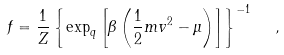<formula> <loc_0><loc_0><loc_500><loc_500>f = \frac { 1 } { Z } \left \{ \exp _ { q } \left [ \beta \left ( \frac { 1 } { 2 } m v ^ { 2 } - \mu \right ) \right ] \right \} ^ { - 1 } \ \ ,</formula> 